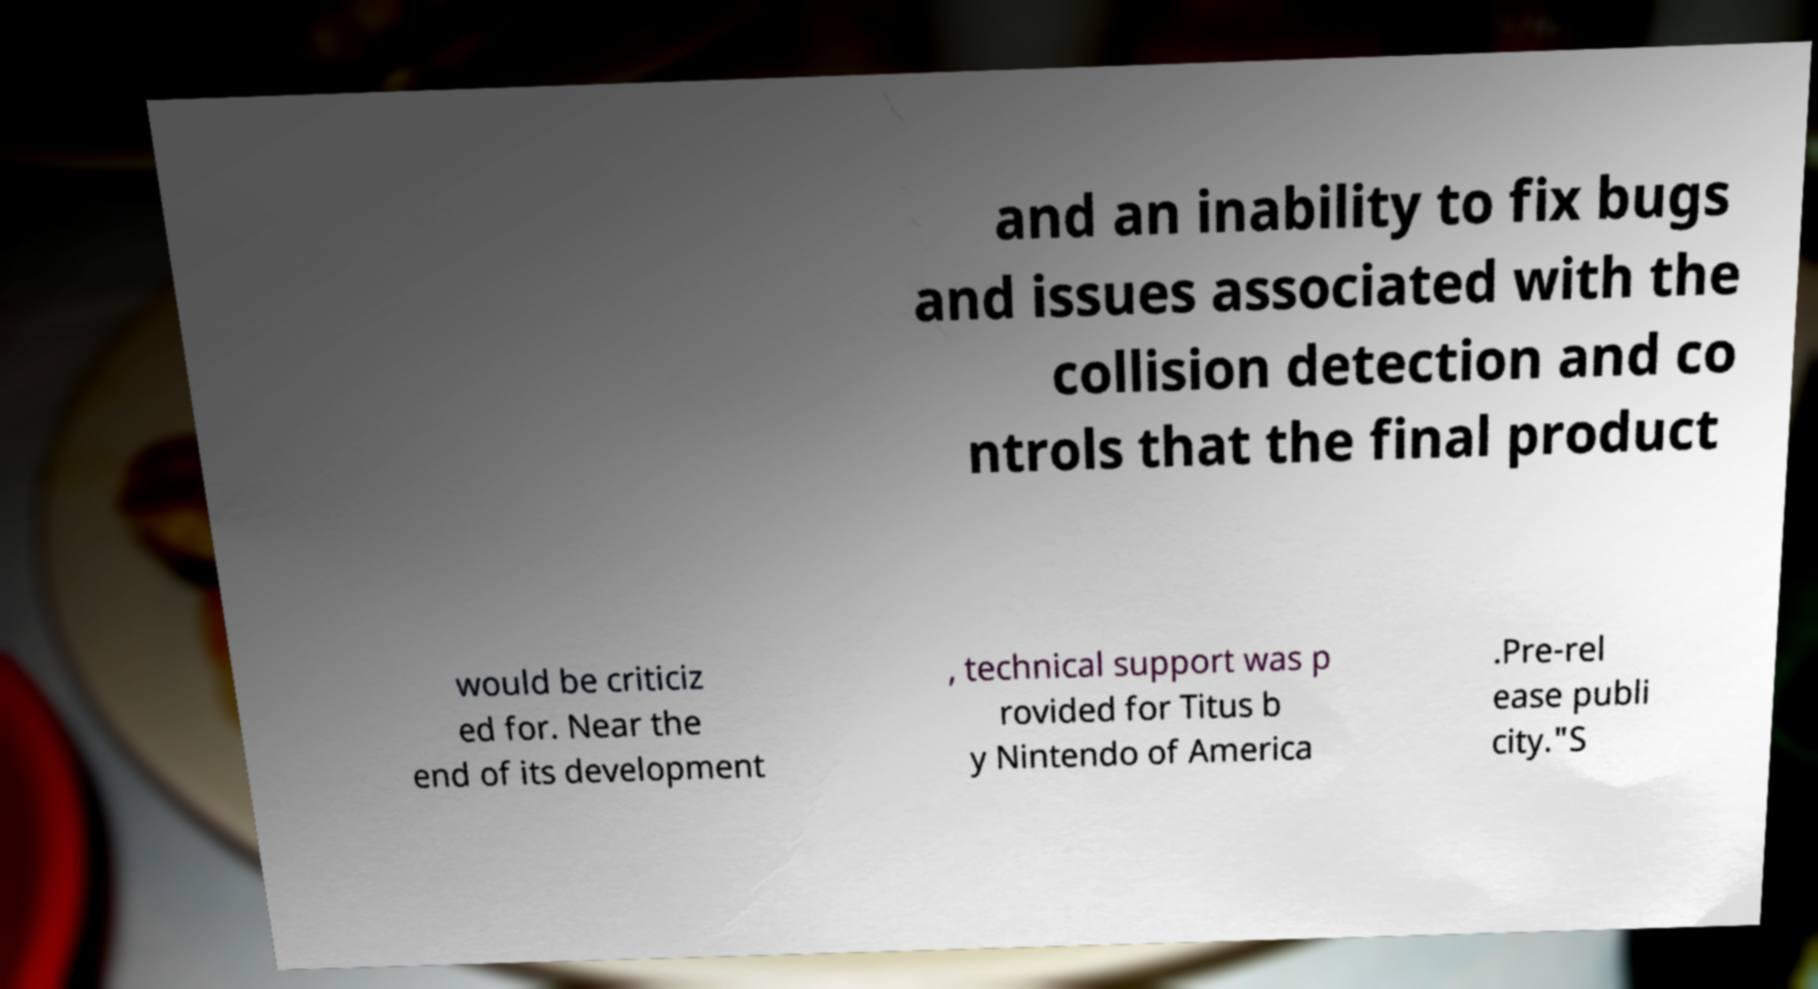For documentation purposes, I need the text within this image transcribed. Could you provide that? and an inability to fix bugs and issues associated with the collision detection and co ntrols that the final product would be criticiz ed for. Near the end of its development , technical support was p rovided for Titus b y Nintendo of America .Pre-rel ease publi city."S 